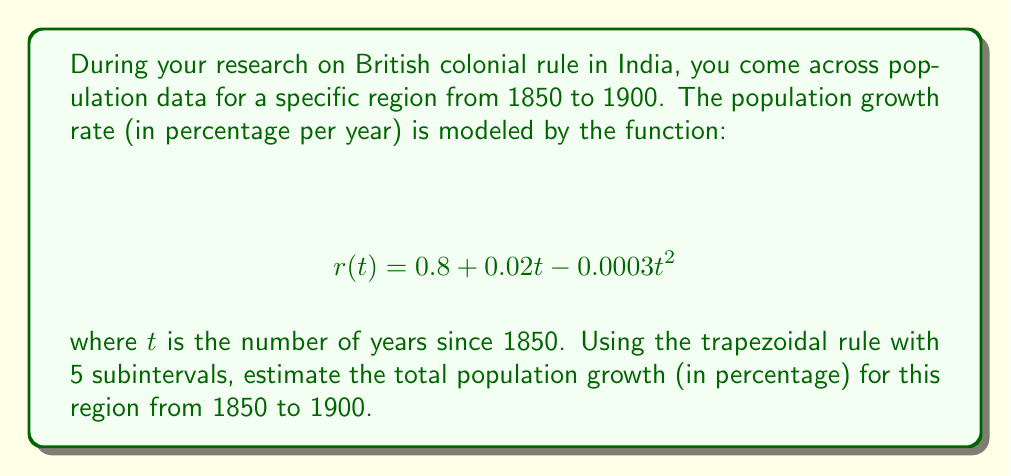Can you answer this question? To solve this problem, we'll use the trapezoidal rule for numerical integration:

1) The integral we need to calculate is:
   $$ \int_{0}^{50} (0.8 + 0.02t - 0.0003t^2) dt $$

2) For the trapezoidal rule with 5 subintervals, we need to divide the interval [0, 50] into 5 equal parts:
   $\Delta t = \frac{50-0}{5} = 10$

3) We need to evaluate $r(t)$ at $t = 0, 10, 20, 30, 40, 50$:
   $r(0) = 0.8$
   $r(10) = 0.8 + 0.2 - 0.03 = 0.97$
   $r(20) = 0.8 + 0.4 - 0.12 = 1.08$
   $r(30) = 0.8 + 0.6 - 0.27 = 1.13$
   $r(40) = 0.8 + 0.8 - 0.48 = 1.12$
   $r(50) = 0.8 + 1.0 - 0.75 = 1.05$

4) Apply the trapezoidal rule:
   $$ \int_{0}^{50} r(t) dt \approx \frac{\Delta t}{2}[r(0) + 2r(10) + 2r(20) + 2r(30) + 2r(40) + r(50)] $$
   $$ = 5[0.8 + 2(0.97) + 2(1.08) + 2(1.13) + 2(1.12) + 1.05] $$
   $$ = 5[0.8 + 1.94 + 2.16 + 2.26 + 2.24 + 1.05] $$
   $$ = 5(10.45) = 52.25 $$

5) Therefore, the estimated total population growth from 1850 to 1900 is 52.25%.
Answer: 52.25% 